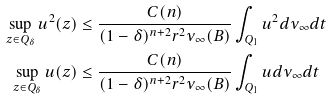Convert formula to latex. <formula><loc_0><loc_0><loc_500><loc_500>\sup _ { z \in Q _ { \delta } } u ^ { 2 } ( z ) & \leq \frac { C ( n ) } { ( 1 - \delta ) ^ { n + 2 } r ^ { 2 } \nu _ { \infty } ( B ) } \int _ { Q _ { 1 } } u ^ { 2 } d \nu _ { \infty } d t \\ \sup _ { z \in Q _ { \delta } } u ( z ) & \leq \frac { C ( n ) } { ( 1 - \delta ) ^ { n + 2 } r ^ { 2 } \nu _ { \infty } ( B ) } \int _ { Q _ { 1 } } u d \nu _ { \infty } d t</formula> 